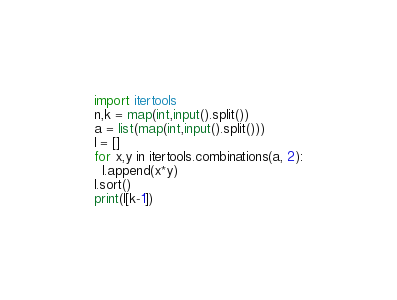<code> <loc_0><loc_0><loc_500><loc_500><_Python_>import itertools
n,k = map(int,input().split())
a = list(map(int,input().split()))
l = []
for x,y in itertools.combinations(a, 2):
  l.append(x*y)
l.sort()  
print(l[k-1])</code> 